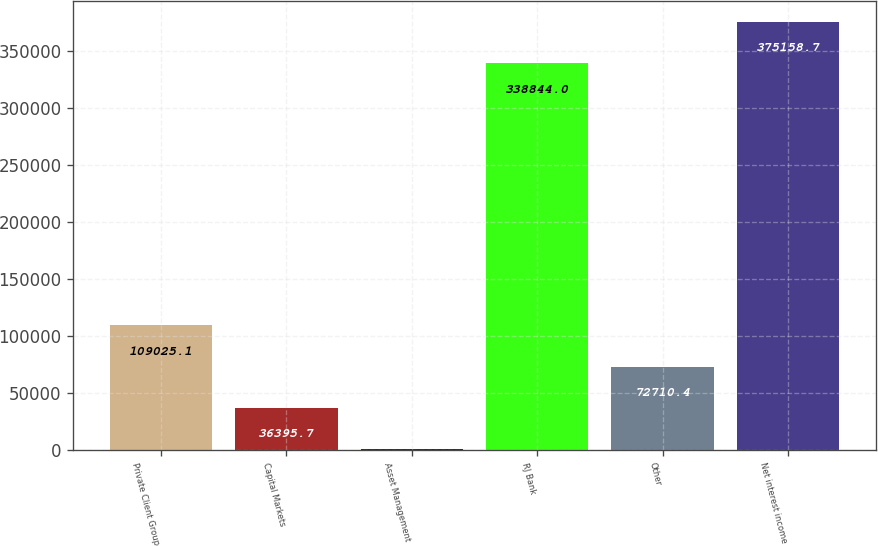<chart> <loc_0><loc_0><loc_500><loc_500><bar_chart><fcel>Private Client Group<fcel>Capital Markets<fcel>Asset Management<fcel>RJ Bank<fcel>Other<fcel>Net interest income<nl><fcel>109025<fcel>36395.7<fcel>81<fcel>338844<fcel>72710.4<fcel>375159<nl></chart> 